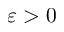<formula> <loc_0><loc_0><loc_500><loc_500>\varepsilon > 0</formula> 